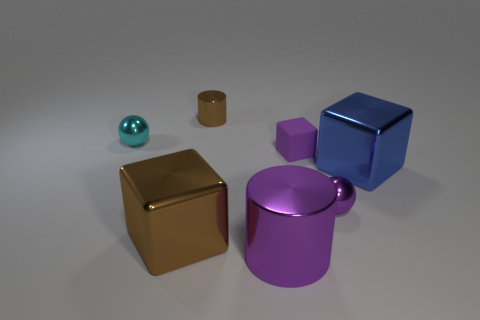There is a purple matte thing right of the large purple cylinder; does it have the same shape as the blue metallic object?
Your response must be concise. Yes. What color is the block that is the same size as the cyan metal thing?
Keep it short and to the point. Purple. How many tiny purple metallic spheres are there?
Provide a succinct answer. 1. Is the large object right of the purple shiny cylinder made of the same material as the purple ball?
Ensure brevity in your answer.  Yes. What is the block that is both in front of the tiny matte thing and on the right side of the tiny cylinder made of?
Keep it short and to the point. Metal. What is the size of the metallic object that is the same color as the small shiny cylinder?
Provide a succinct answer. Large. There is a tiny purple cube that is behind the large thing to the left of the large purple cylinder; what is it made of?
Your answer should be very brief. Rubber. There is a brown object that is behind the big cube that is behind the shiny ball that is on the right side of the small cyan metallic thing; how big is it?
Your answer should be very brief. Small. How many balls have the same material as the big brown thing?
Your response must be concise. 2. The small metallic ball that is to the left of the large cube on the left side of the brown cylinder is what color?
Provide a succinct answer. Cyan. 